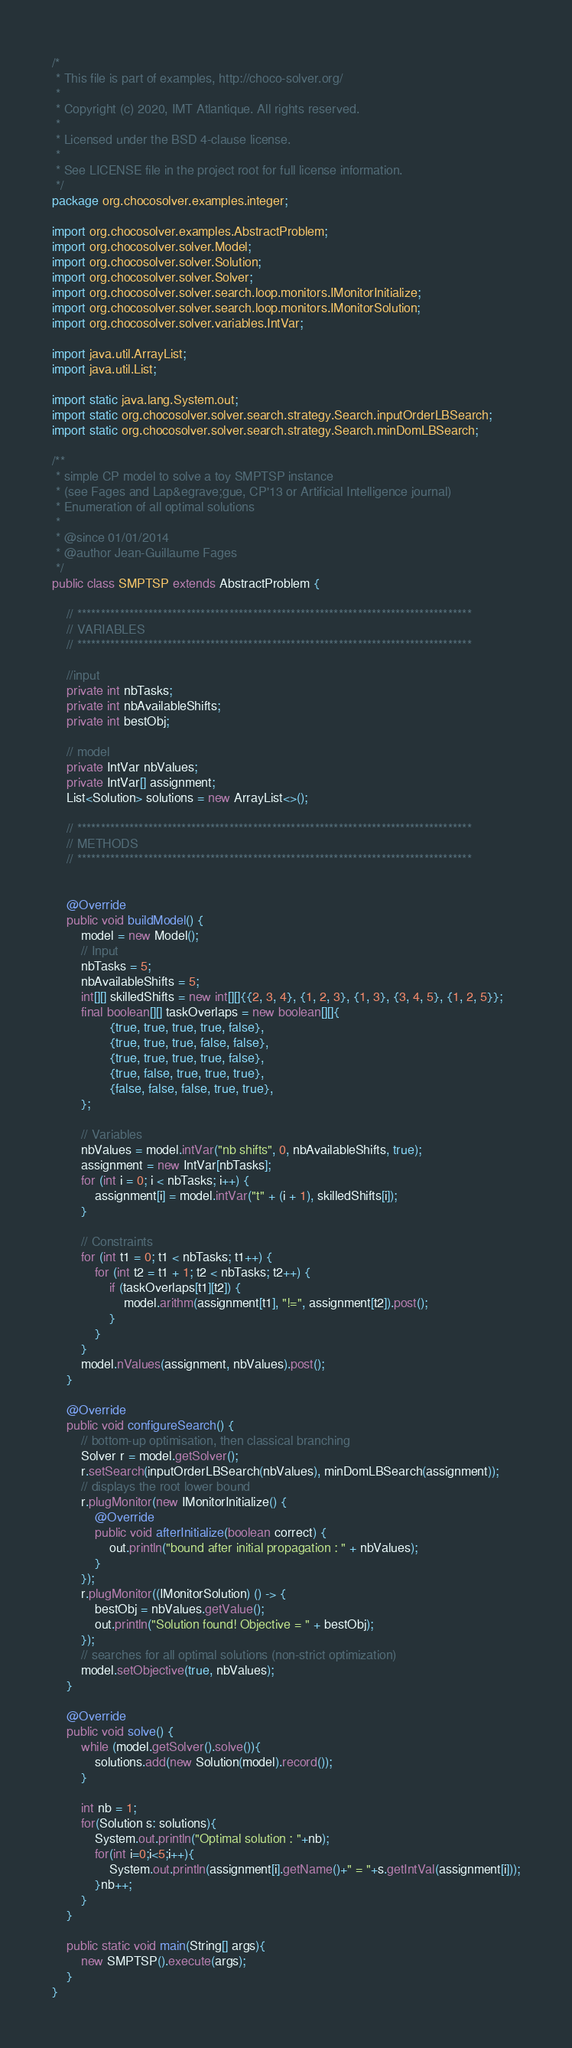<code> <loc_0><loc_0><loc_500><loc_500><_Java_>/*
 * This file is part of examples, http://choco-solver.org/
 *
 * Copyright (c) 2020, IMT Atlantique. All rights reserved.
 *
 * Licensed under the BSD 4-clause license.
 *
 * See LICENSE file in the project root for full license information.
 */
package org.chocosolver.examples.integer;

import org.chocosolver.examples.AbstractProblem;
import org.chocosolver.solver.Model;
import org.chocosolver.solver.Solution;
import org.chocosolver.solver.Solver;
import org.chocosolver.solver.search.loop.monitors.IMonitorInitialize;
import org.chocosolver.solver.search.loop.monitors.IMonitorSolution;
import org.chocosolver.solver.variables.IntVar;

import java.util.ArrayList;
import java.util.List;

import static java.lang.System.out;
import static org.chocosolver.solver.search.strategy.Search.inputOrderLBSearch;
import static org.chocosolver.solver.search.strategy.Search.minDomLBSearch;

/**
 * simple CP model to solve a toy SMPTSP instance
 * (see Fages and Lap&egrave;gue, CP'13 or Artificial Intelligence journal)
 * Enumeration of all optimal solutions
 *
 * @since 01/01/2014
 * @author Jean-Guillaume Fages
 */
public class SMPTSP extends AbstractProblem {

	// ***********************************************************************************
	// VARIABLES
	// ***********************************************************************************

	//input
	private int nbTasks;
	private int nbAvailableShifts;
	private int bestObj;

	// model
	private IntVar nbValues;
	private IntVar[] assignment;
	List<Solution> solutions = new ArrayList<>();

	// ***********************************************************************************
	// METHODS
	// ***********************************************************************************


	@Override
	public void buildModel() {
		model = new Model();
		// Input
		nbTasks = 5;
		nbAvailableShifts = 5;
		int[][] skilledShifts = new int[][]{{2, 3, 4}, {1, 2, 3}, {1, 3}, {3, 4, 5}, {1, 2, 5}};
		final boolean[][] taskOverlaps = new boolean[][]{
				{true, true, true, true, false},
				{true, true, true, false, false},
				{true, true, true, true, false},
				{true, false, true, true, true},
				{false, false, false, true, true},
		};

		// Variables
		nbValues = model.intVar("nb shifts", 0, nbAvailableShifts, true);
		assignment = new IntVar[nbTasks];
		for (int i = 0; i < nbTasks; i++) {
			assignment[i] = model.intVar("t" + (i + 1), skilledShifts[i]);
		}

		// Constraints
		for (int t1 = 0; t1 < nbTasks; t1++) {
			for (int t2 = t1 + 1; t2 < nbTasks; t2++) {
				if (taskOverlaps[t1][t2]) {
					model.arithm(assignment[t1], "!=", assignment[t2]).post();
				}
			}
		}
		model.nValues(assignment, nbValues).post();
	}

	@Override
	public void configureSearch() {
		// bottom-up optimisation, then classical branching
		Solver r = model.getSolver();
		r.setSearch(inputOrderLBSearch(nbValues), minDomLBSearch(assignment));
		// displays the root lower bound
		r.plugMonitor(new IMonitorInitialize() {
			@Override
			public void afterInitialize(boolean correct) {
				out.println("bound after initial propagation : " + nbValues);
			}
		});
		r.plugMonitor((IMonitorSolution) () -> {
			bestObj = nbValues.getValue();
			out.println("Solution found! Objective = " + bestObj);
		});
		// searches for all optimal solutions (non-strict optimization)
		model.setObjective(true, nbValues);
	}

	@Override
	public void solve() {
		while (model.getSolver().solve()){
            solutions.add(new Solution(model).record());
        }

		int nb = 1;
		for(Solution s: solutions){
			System.out.println("Optimal solution : "+nb);
			for(int i=0;i<5;i++){
				System.out.println(assignment[i].getName()+" = "+s.getIntVal(assignment[i]));
			}nb++;
		}
	}

	public static void main(String[] args){
		new SMPTSP().execute(args);
	}
}
</code> 